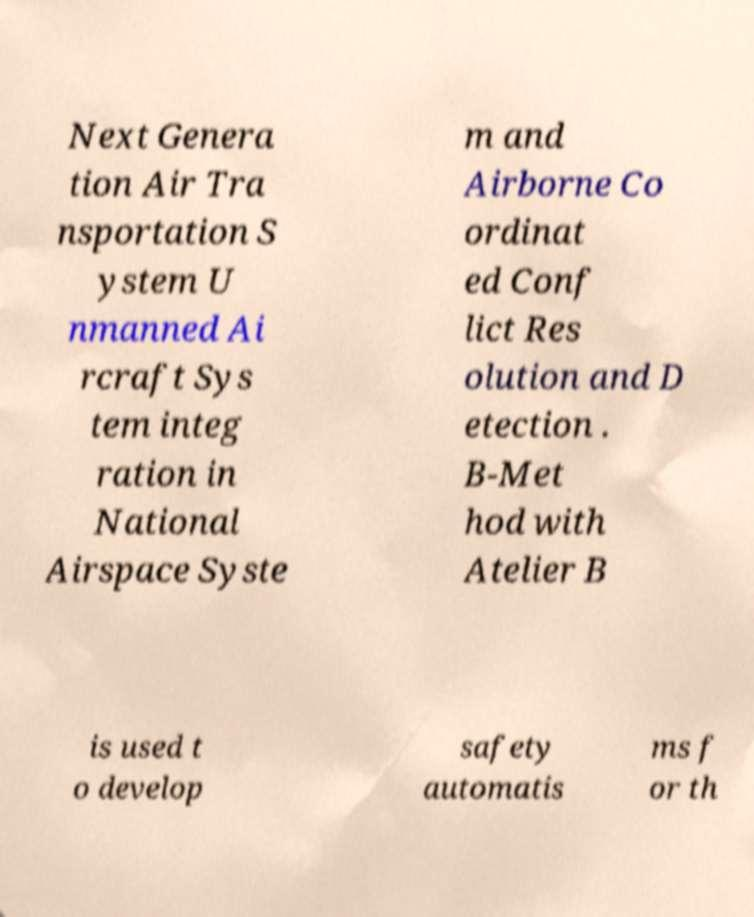There's text embedded in this image that I need extracted. Can you transcribe it verbatim? Next Genera tion Air Tra nsportation S ystem U nmanned Ai rcraft Sys tem integ ration in National Airspace Syste m and Airborne Co ordinat ed Conf lict Res olution and D etection . B-Met hod with Atelier B is used t o develop safety automatis ms f or th 